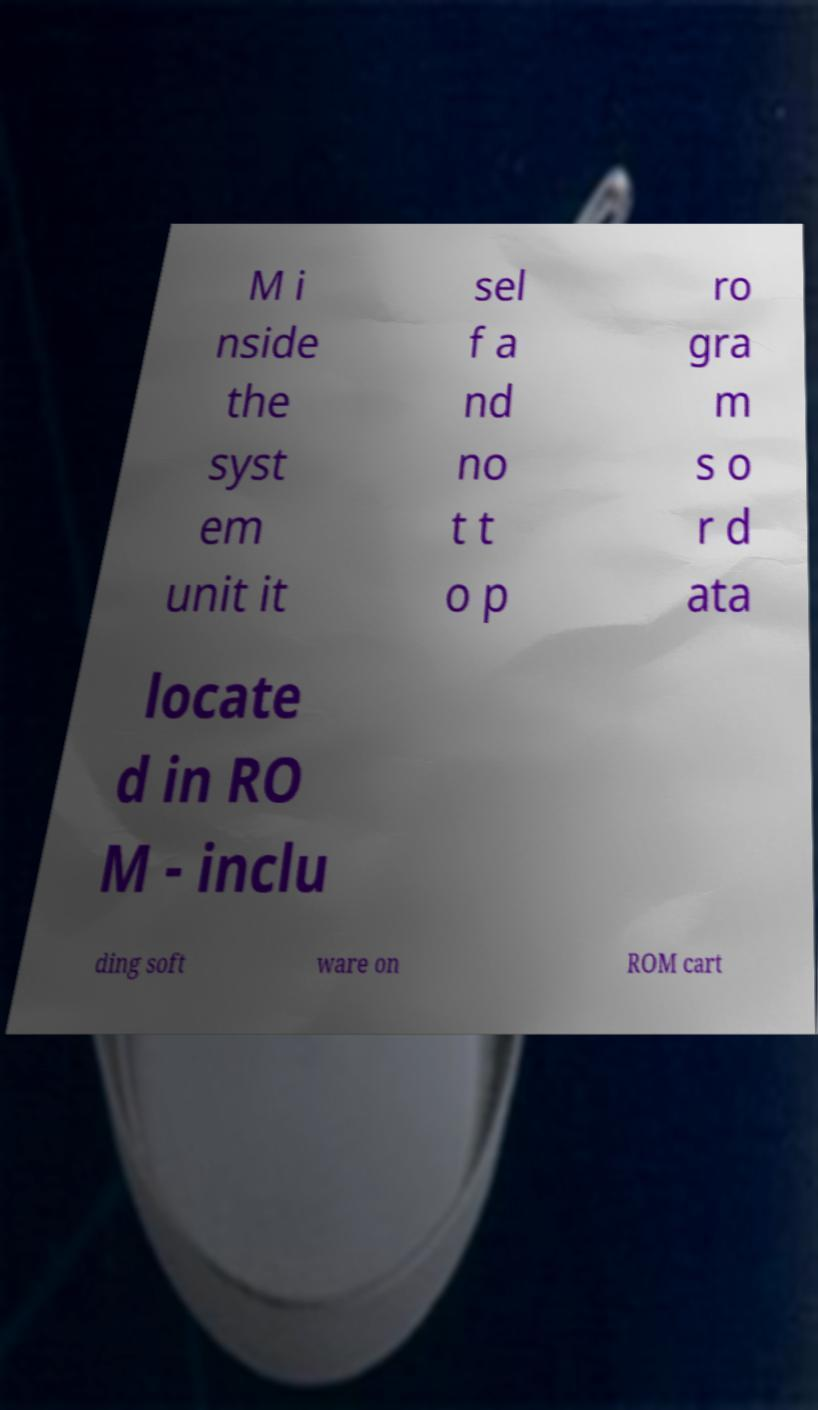Can you accurately transcribe the text from the provided image for me? M i nside the syst em unit it sel f a nd no t t o p ro gra m s o r d ata locate d in RO M - inclu ding soft ware on ROM cart 